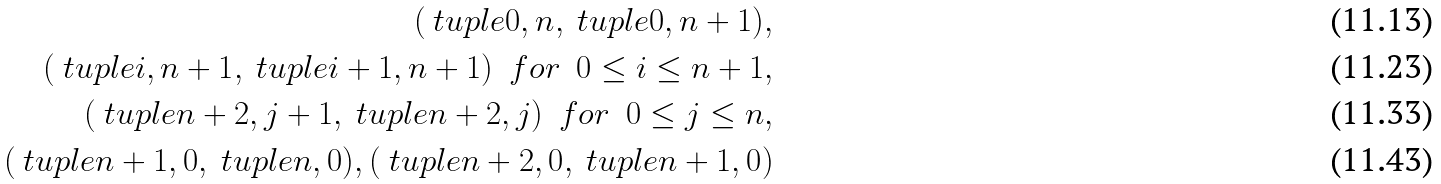<formula> <loc_0><loc_0><loc_500><loc_500>( \ t u p l e { 0 , n } , \ t u p l e { 0 , n + 1 } ) , \\ ( \ t u p l e { i , n + 1 } , \ t u p l e { i + 1 , n + 1 } ) \ \ f o r \ \ 0 \leq i \leq n + 1 , \\ ( \ t u p l e { n + 2 , j + 1 } , \ t u p l e { n + 2 , j } ) \ \ f o r \ \ 0 \leq j \leq n , \\ ( \ t u p l e { n + 1 , 0 } , \ t u p l e { n , 0 } ) , ( \ t u p l e { n + 2 , 0 } , \ t u p l e { n + 1 , 0 } )</formula> 